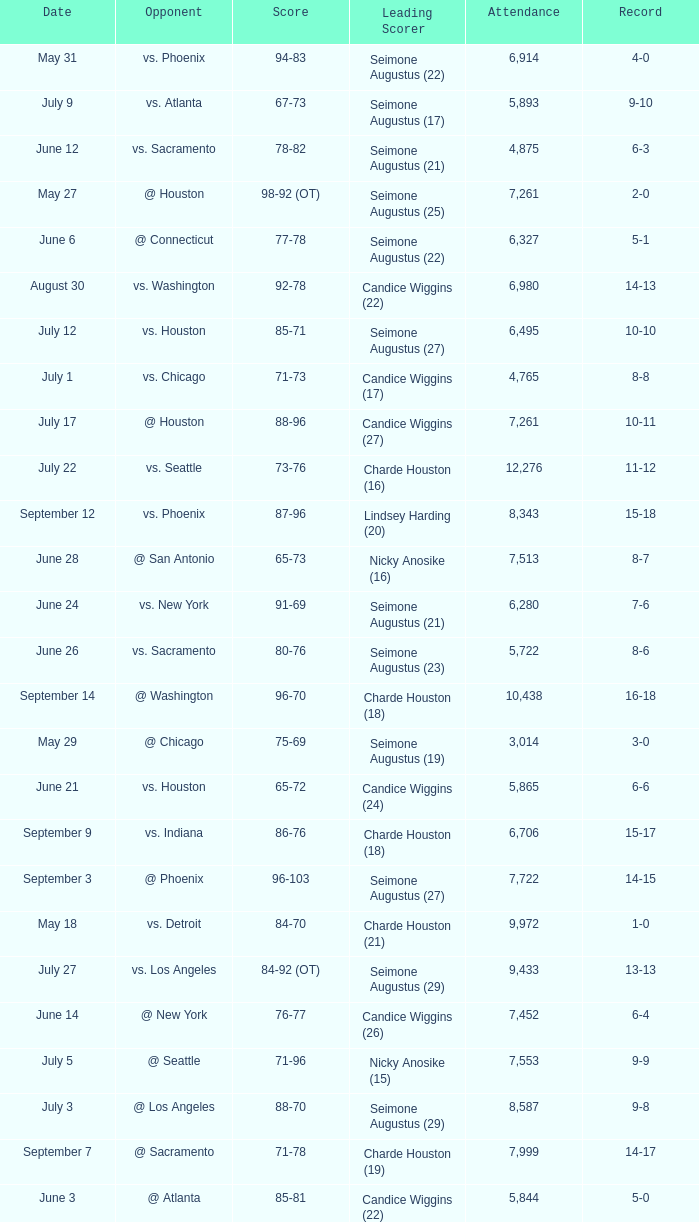Which Score has an Opponent of @ houston, and a Record of 2-0? 98-92 (OT). 